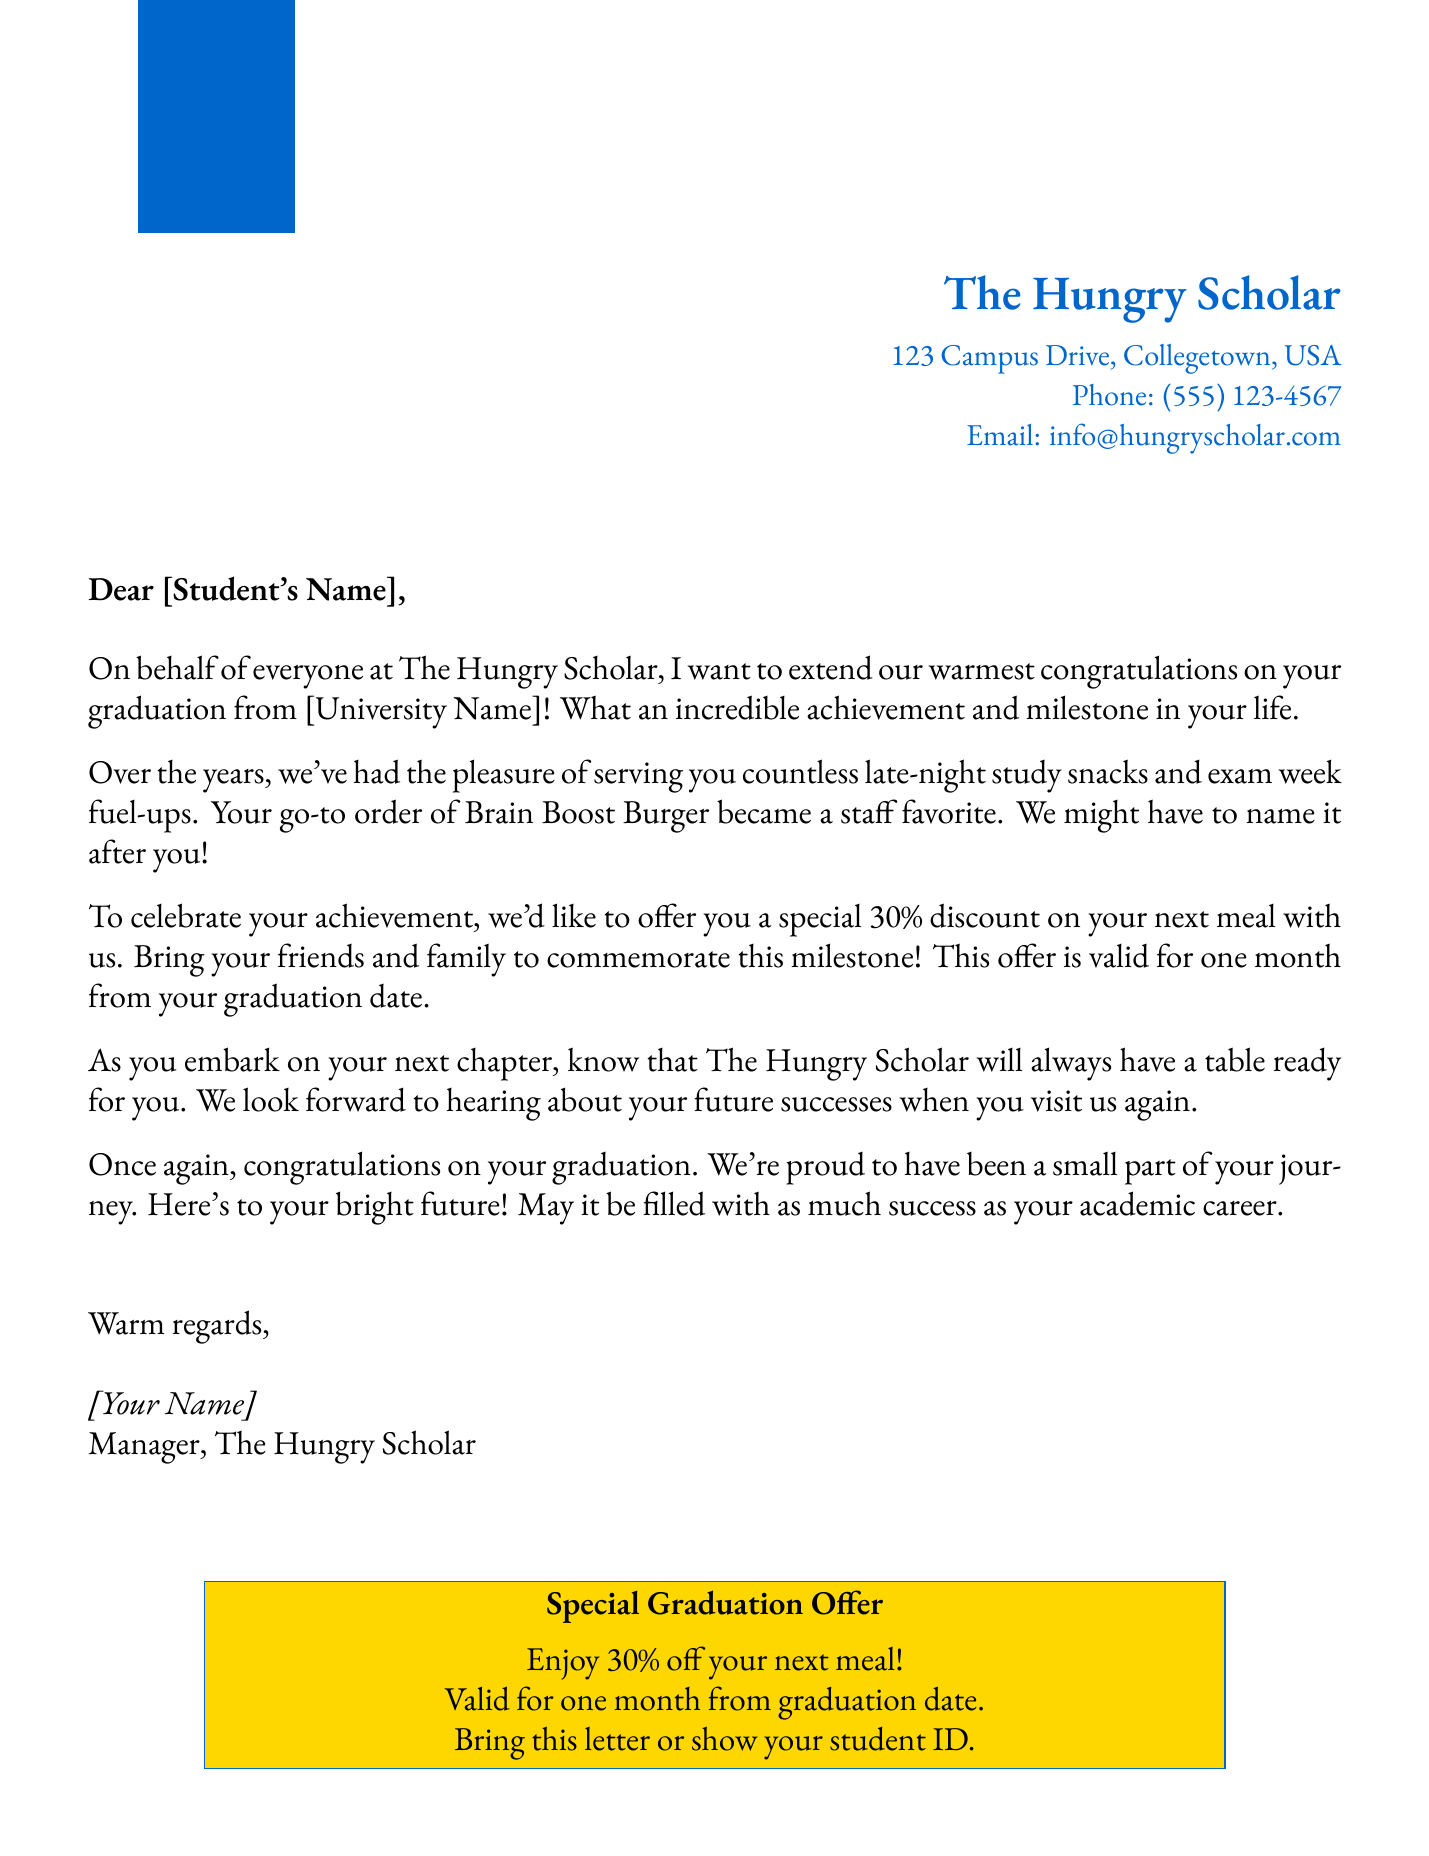what is the name of the restaurant? The document states the restaurant’s name which is The Hungry Scholar.
Answer: The Hungry Scholar what discount percentage is offered to the graduate? The letter mentions a special 30% discount for the graduate's next meal.
Answer: 30% who is the letter addressed to? The salutation indicates that the letter is addressed to a student whose name would be substituted there.
Answer: [Student's Name] what is the validity period of the discount offer? The document specifies that the discount offer is valid for one month from the graduation date.
Answer: one month what dish became a staff favorite? The letter refers to a specific dish ordered by the student, which is the Brain Boost Burger.
Answer: Brain Boost Burger how does the restaurant recognize the student's loyalty? The document outlines that the restaurant acknowledges the student's regular visits during their academic journey.
Answer: Regular visits what is enclosed in a special box at the end of the letter? A promotional offer with details is placed in a colored box to highlight the discount.
Answer: Special Graduation Offer what is the contact method listed for the restaurant? The letter provides an email address as a contact method for the restaurant.
Answer: info@hungryscholar.com what is the signature of the letter? The closing section includes the name and title of the sender, indicating who wrote the letter.
Answer: [Your Name], Manager, The Hungry Scholar 